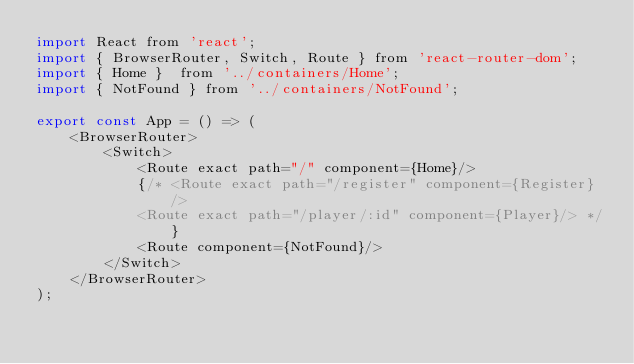Convert code to text. <code><loc_0><loc_0><loc_500><loc_500><_JavaScript_>import React from 'react';
import { BrowserRouter, Switch, Route } from 'react-router-dom';
import { Home }  from '../containers/Home';
import { NotFound } from '../containers/NotFound';

export const App = () => (
    <BrowserRouter>
        <Switch>
            <Route exact path="/" component={Home}/>
            {/* <Route exact path="/register" component={Register} />
            <Route exact path="/player/:id" component={Player}/> */}
            <Route component={NotFound}/>
        </Switch>
    </BrowserRouter>
);</code> 